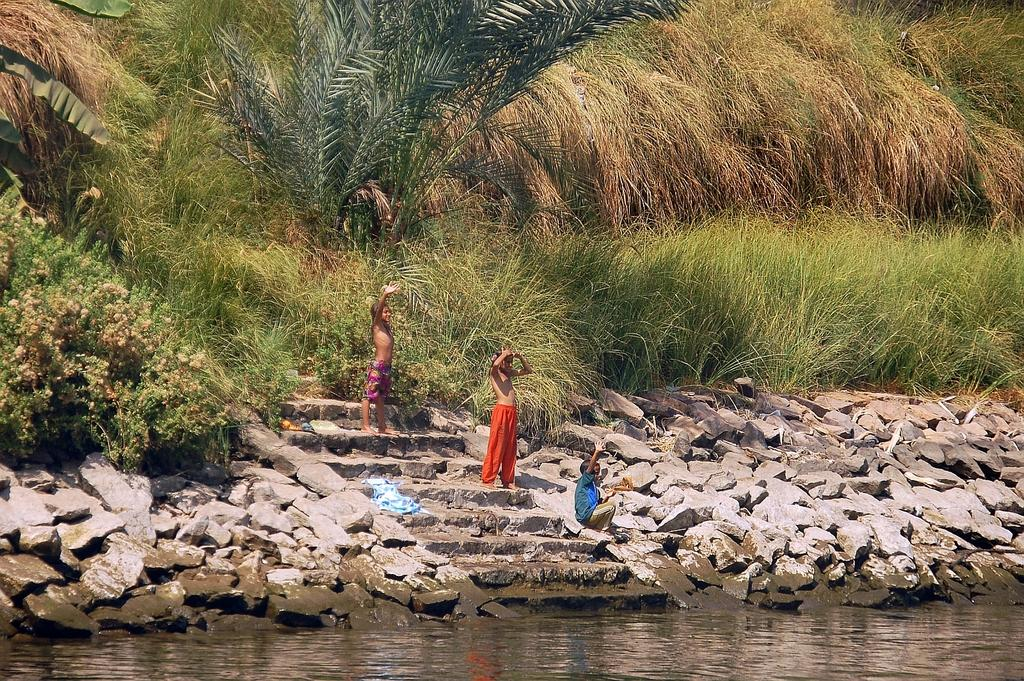How many children are present in the image? There are children in the image, with two standing and one sitting. What can be seen in the background of the image? There are stairs, stones, water, grass, and plants visible in the image. What type of stone is being used as a box to store apples in the image? There is no stone or box for storing apples present in the image. 